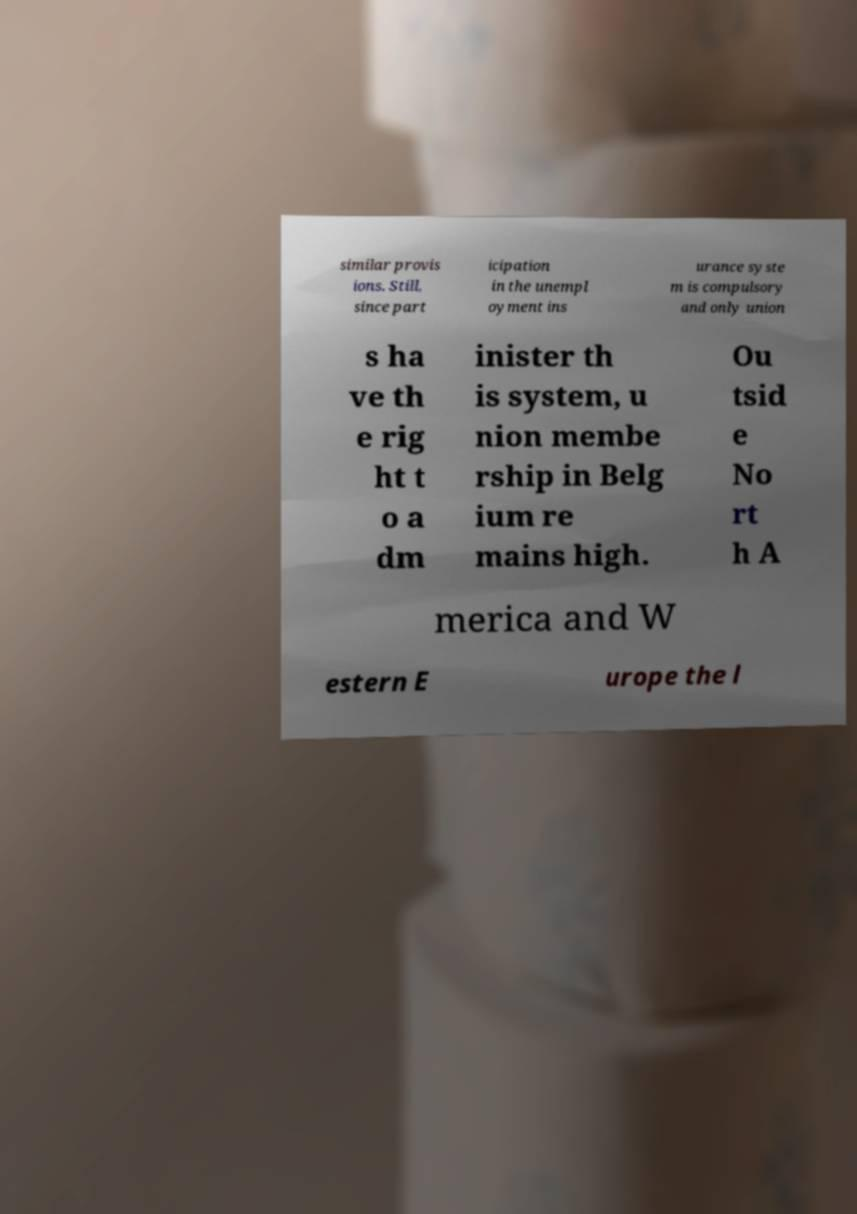Please identify and transcribe the text found in this image. similar provis ions. Still, since part icipation in the unempl oyment ins urance syste m is compulsory and only union s ha ve th e rig ht t o a dm inister th is system, u nion membe rship in Belg ium re mains high. Ou tsid e No rt h A merica and W estern E urope the l 